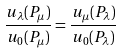Convert formula to latex. <formula><loc_0><loc_0><loc_500><loc_500>\frac { u _ { \lambda } ( P _ { \mu } ) } { u _ { 0 } ( P _ { \mu } ) } = \frac { u _ { \mu } ( P _ { \lambda } ) } { u _ { 0 } ( P _ { \lambda } ) }</formula> 